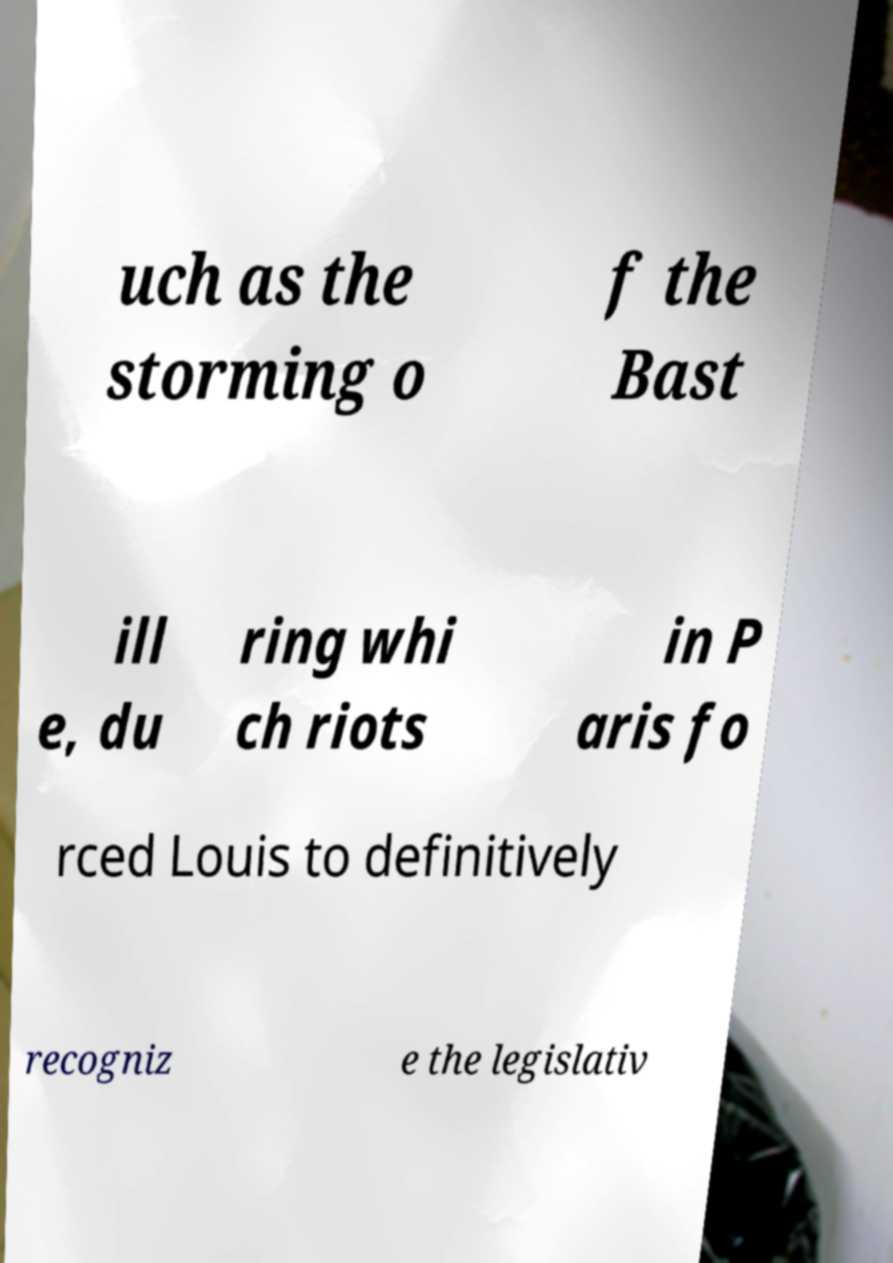For documentation purposes, I need the text within this image transcribed. Could you provide that? uch as the storming o f the Bast ill e, du ring whi ch riots in P aris fo rced Louis to definitively recogniz e the legislativ 